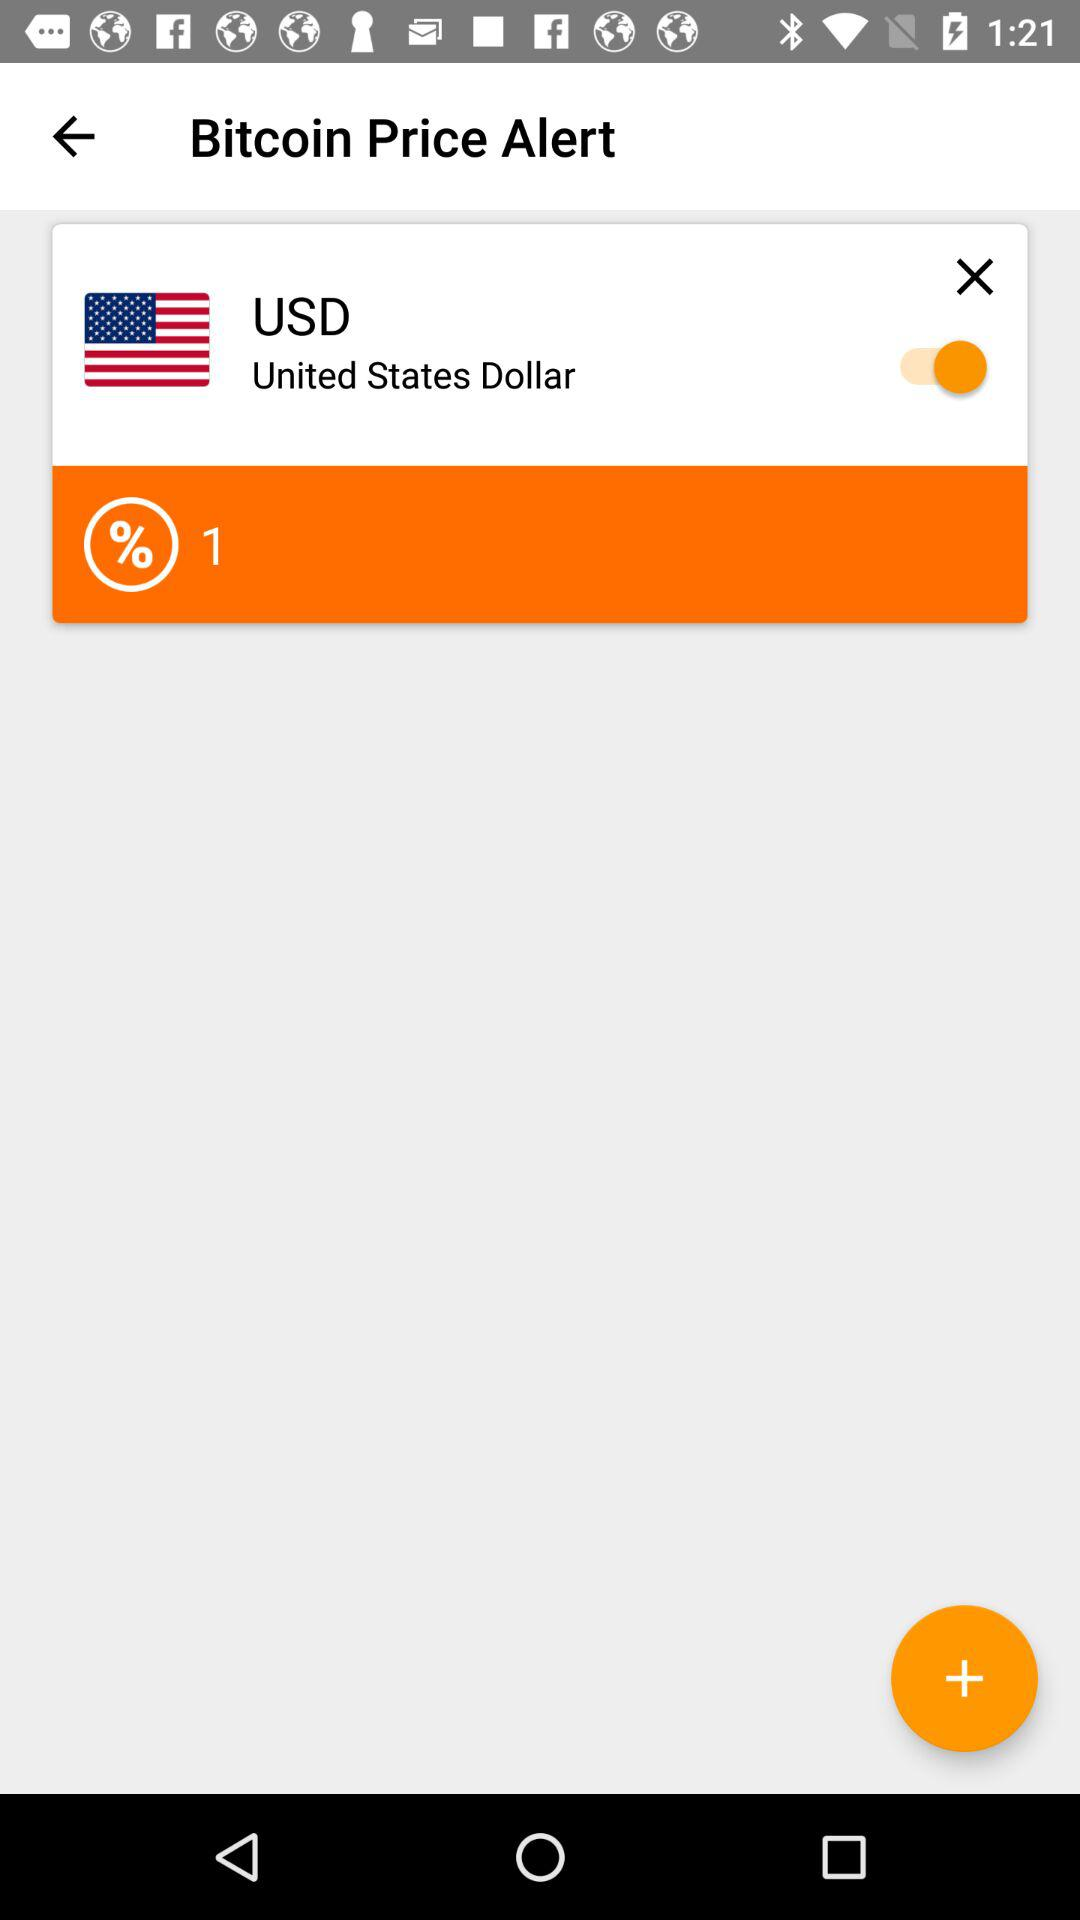How much is the percentage change?
Answer the question using a single word or phrase. 1 